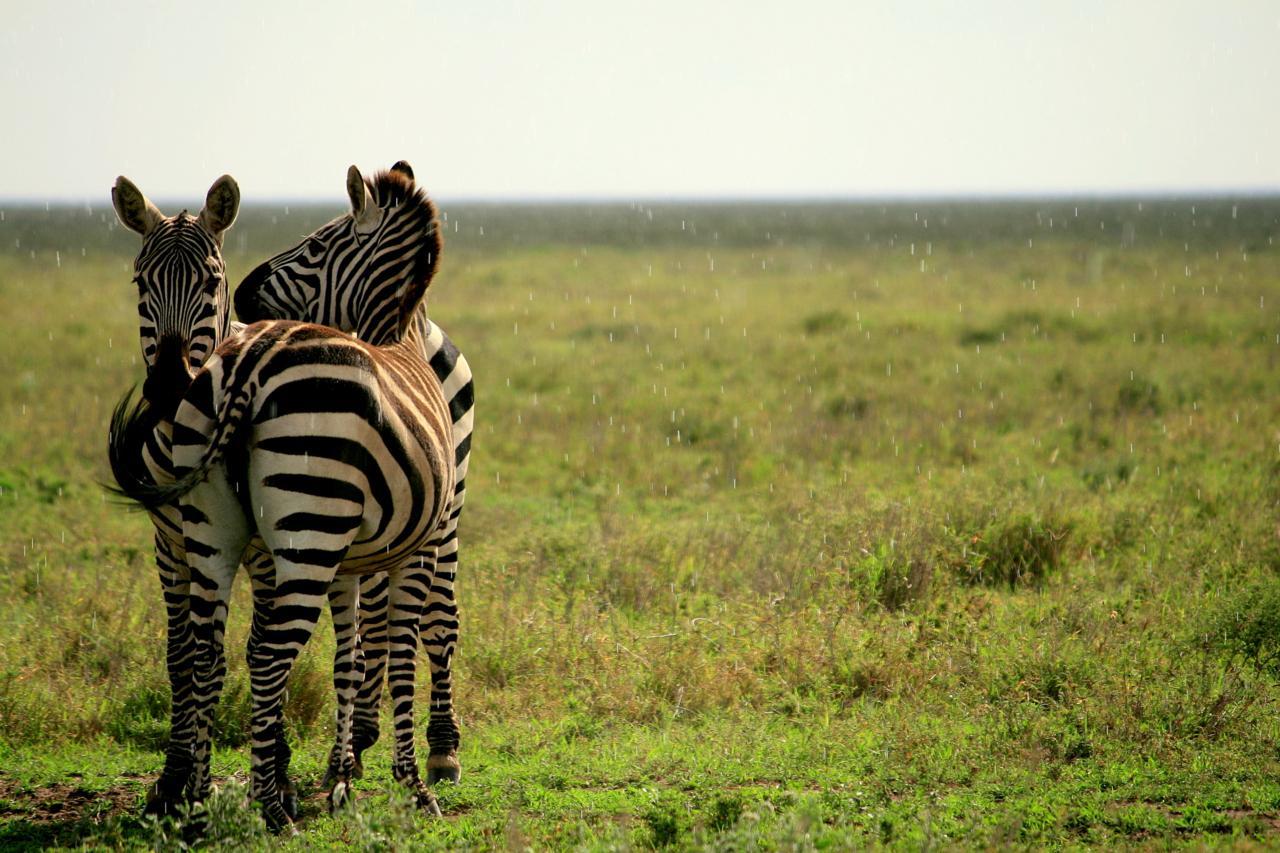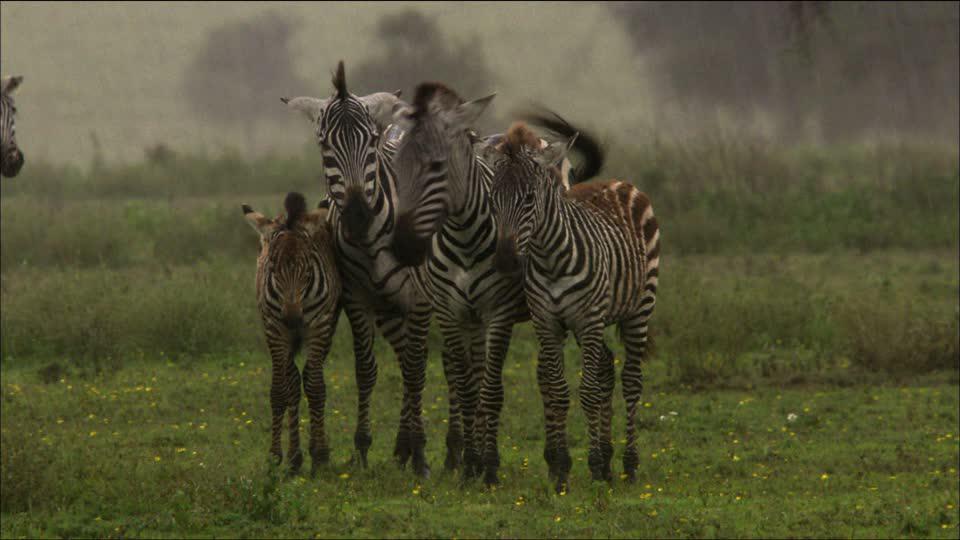The first image is the image on the left, the second image is the image on the right. Evaluate the accuracy of this statement regarding the images: "There are more than four zebras in each image.". Is it true? Answer yes or no. No. The first image is the image on the left, the second image is the image on the right. Evaluate the accuracy of this statement regarding the images: "The right image contains no more than five zebras.". Is it true? Answer yes or no. Yes. 